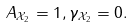<formula> <loc_0><loc_0><loc_500><loc_500>A _ { \mathcal { X } _ { 2 } } = 1 , \gamma _ { \mathcal { X } _ { 2 } } = 0 .</formula> 